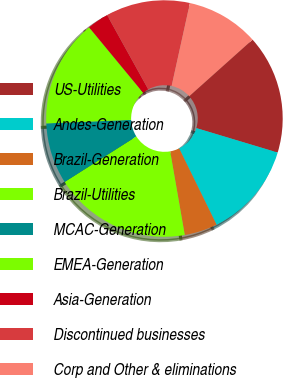Convert chart to OTSL. <chart><loc_0><loc_0><loc_500><loc_500><pie_chart><fcel>US-Utilities<fcel>Andes-Generation<fcel>Brazil-Generation<fcel>Brazil-Utilities<fcel>MCAC-Generation<fcel>EMEA-Generation<fcel>Asia-Generation<fcel>Discontinued businesses<fcel>Corp and Other & eliminations<nl><fcel>16.26%<fcel>13.09%<fcel>4.51%<fcel>18.74%<fcel>8.35%<fcel>14.67%<fcel>2.93%<fcel>11.51%<fcel>9.93%<nl></chart> 